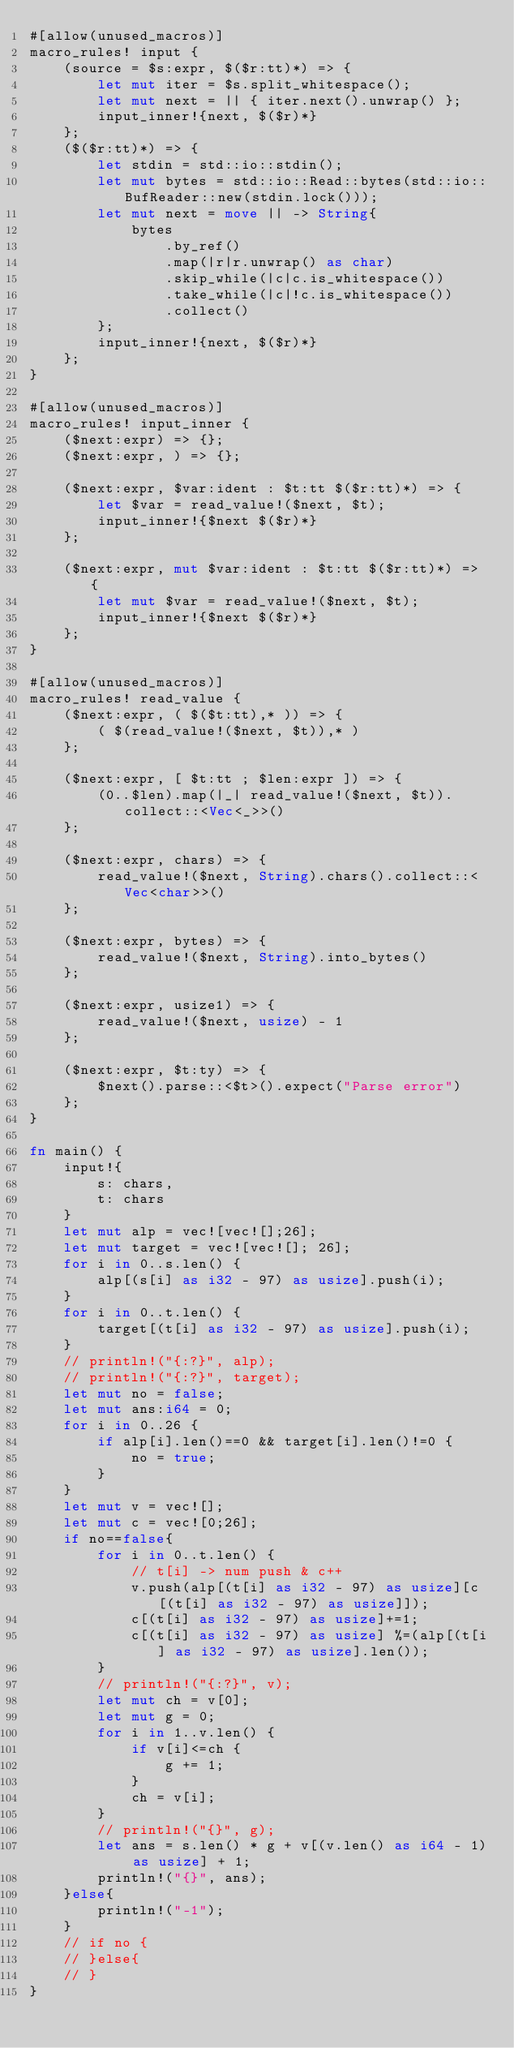Convert code to text. <code><loc_0><loc_0><loc_500><loc_500><_Rust_>#[allow(unused_macros)]
macro_rules! input {
    (source = $s:expr, $($r:tt)*) => {
        let mut iter = $s.split_whitespace();
        let mut next = || { iter.next().unwrap() };
        input_inner!{next, $($r)*}
    };
    ($($r:tt)*) => {
        let stdin = std::io::stdin();
        let mut bytes = std::io::Read::bytes(std::io::BufReader::new(stdin.lock()));
        let mut next = move || -> String{
            bytes
                .by_ref()
                .map(|r|r.unwrap() as char)
                .skip_while(|c|c.is_whitespace())
                .take_while(|c|!c.is_whitespace())
                .collect()
        };
        input_inner!{next, $($r)*}
    };
}

#[allow(unused_macros)]
macro_rules! input_inner {
    ($next:expr) => {};
    ($next:expr, ) => {};

    ($next:expr, $var:ident : $t:tt $($r:tt)*) => {
        let $var = read_value!($next, $t);
        input_inner!{$next $($r)*}
    };

    ($next:expr, mut $var:ident : $t:tt $($r:tt)*) => {
        let mut $var = read_value!($next, $t);
        input_inner!{$next $($r)*}
    };
}

#[allow(unused_macros)]
macro_rules! read_value {
    ($next:expr, ( $($t:tt),* )) => {
        ( $(read_value!($next, $t)),* )
    };

    ($next:expr, [ $t:tt ; $len:expr ]) => {
        (0..$len).map(|_| read_value!($next, $t)).collect::<Vec<_>>()
    };

    ($next:expr, chars) => {
        read_value!($next, String).chars().collect::<Vec<char>>()
    };

    ($next:expr, bytes) => {
        read_value!($next, String).into_bytes()
    };

    ($next:expr, usize1) => {
        read_value!($next, usize) - 1
    };

    ($next:expr, $t:ty) => {
        $next().parse::<$t>().expect("Parse error")
    };
}

fn main() {
    input!{
        s: chars,
        t: chars
    }
    let mut alp = vec![vec![];26];
    let mut target = vec![vec![]; 26];
    for i in 0..s.len() {
        alp[(s[i] as i32 - 97) as usize].push(i);
    }
    for i in 0..t.len() {
        target[(t[i] as i32 - 97) as usize].push(i);
    }
    // println!("{:?}", alp);
    // println!("{:?}", target);
    let mut no = false;
    let mut ans:i64 = 0;
    for i in 0..26 {
        if alp[i].len()==0 && target[i].len()!=0 {
            no = true;
        }
    }
    let mut v = vec![];
    let mut c = vec![0;26];
    if no==false{
        for i in 0..t.len() {
            // t[i] -> num push & c++
            v.push(alp[(t[i] as i32 - 97) as usize][c[(t[i] as i32 - 97) as usize]]);
            c[(t[i] as i32 - 97) as usize]+=1;
            c[(t[i] as i32 - 97) as usize] %=(alp[(t[i] as i32 - 97) as usize].len());
        }
        // println!("{:?}", v);
        let mut ch = v[0];
        let mut g = 0;
        for i in 1..v.len() {
            if v[i]<=ch {
                g += 1;
            }
            ch = v[i];
        }
        // println!("{}", g);
        let ans = s.len() * g + v[(v.len() as i64 - 1) as usize] + 1;
        println!("{}", ans);
    }else{
        println!("-1");
    }
    // if no {
    // }else{
    // }
}</code> 